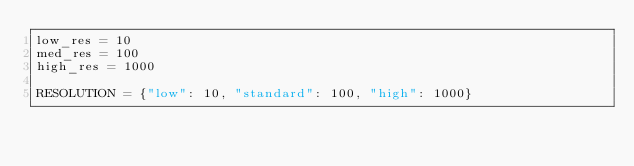Convert code to text. <code><loc_0><loc_0><loc_500><loc_500><_Python_>low_res = 10
med_res = 100
high_res = 1000

RESOLUTION = {"low": 10, "standard": 100, "high": 1000}
</code> 